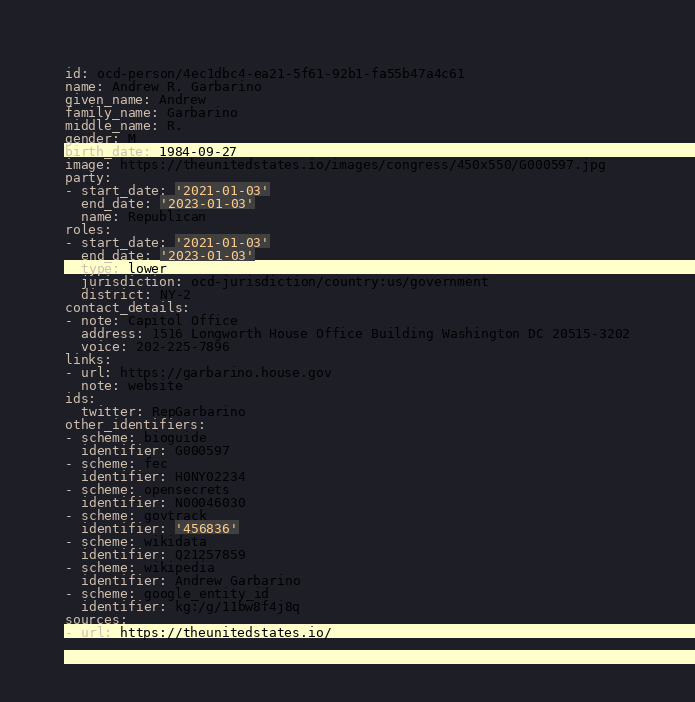<code> <loc_0><loc_0><loc_500><loc_500><_YAML_>id: ocd-person/4ec1dbc4-ea21-5f61-92b1-fa55b47a4c61
name: Andrew R. Garbarino
given_name: Andrew
family_name: Garbarino
middle_name: R.
gender: M
birth_date: 1984-09-27
image: https://theunitedstates.io/images/congress/450x550/G000597.jpg
party:
- start_date: '2021-01-03'
  end_date: '2023-01-03'
  name: Republican
roles:
- start_date: '2021-01-03'
  end_date: '2023-01-03'
  type: lower
  jurisdiction: ocd-jurisdiction/country:us/government
  district: NY-2
contact_details:
- note: Capitol Office
  address: 1516 Longworth House Office Building Washington DC 20515-3202
  voice: 202-225-7896
links:
- url: https://garbarino.house.gov
  note: website
ids:
  twitter: RepGarbarino
other_identifiers:
- scheme: bioguide
  identifier: G000597
- scheme: fec
  identifier: H0NY02234
- scheme: opensecrets
  identifier: N00046030
- scheme: govtrack
  identifier: '456836'
- scheme: wikidata
  identifier: Q21257859
- scheme: wikipedia
  identifier: Andrew Garbarino
- scheme: google_entity_id
  identifier: kg:/g/11bw8f4j8q
sources:
- url: https://theunitedstates.io/
</code> 